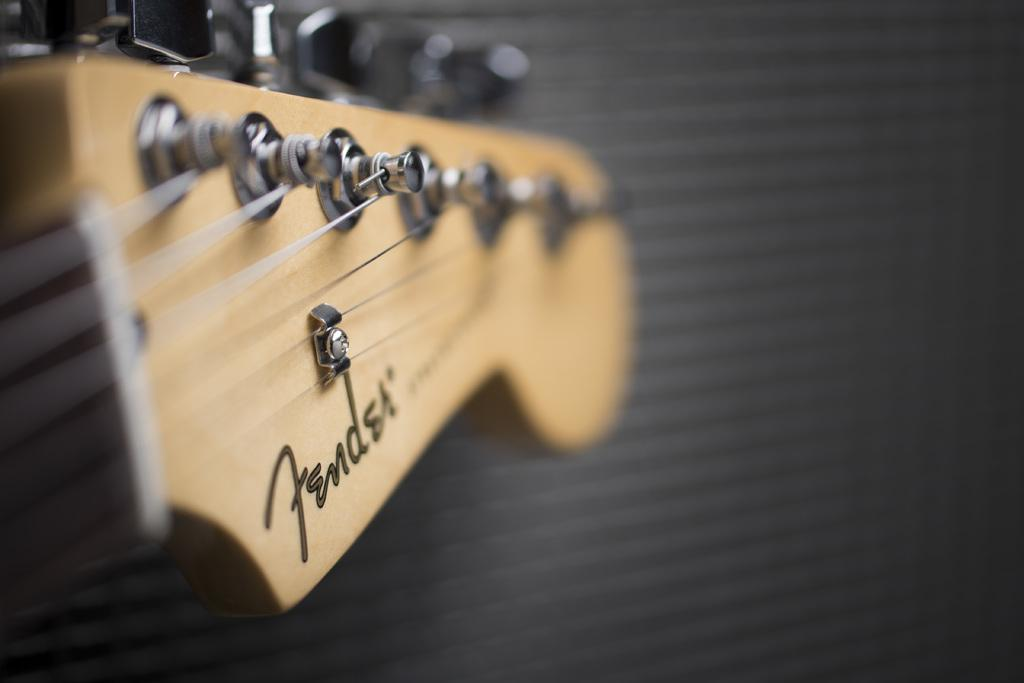What musical instrument is present in the image? There is a guitar in the image. What type of stew is being cooked on the guitar in the image? There is no stew or cooking activity present in the image; it features a guitar. How many eggs are visible on the guitar in the image? There are no eggs present in the image; it features a guitar. 